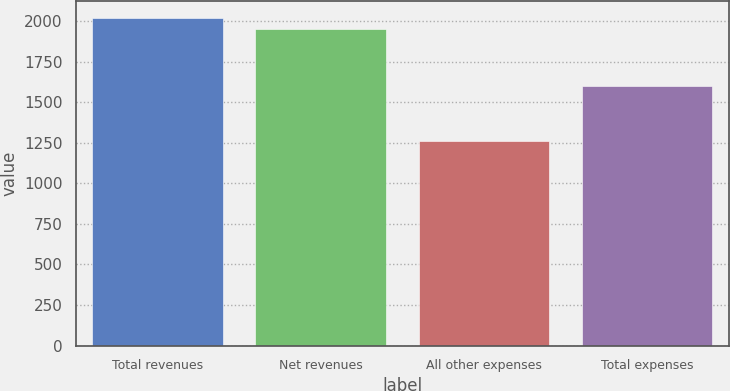Convert chart to OTSL. <chart><loc_0><loc_0><loc_500><loc_500><bar_chart><fcel>Total revenues<fcel>Net revenues<fcel>All other expenses<fcel>Total expenses<nl><fcel>2023.3<fcel>1954<fcel>1262<fcel>1602<nl></chart> 